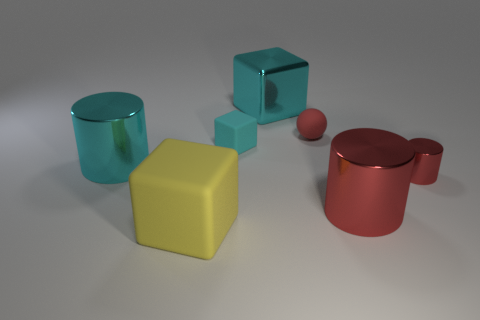Subtract all red cylinders. How many were subtracted if there are1red cylinders left? 1 Add 3 tiny blocks. How many objects exist? 10 Subtract 0 brown spheres. How many objects are left? 7 Subtract all cylinders. How many objects are left? 4 Subtract all small gray rubber blocks. Subtract all big yellow cubes. How many objects are left? 6 Add 2 yellow cubes. How many yellow cubes are left? 3 Add 3 tiny blue cylinders. How many tiny blue cylinders exist? 3 